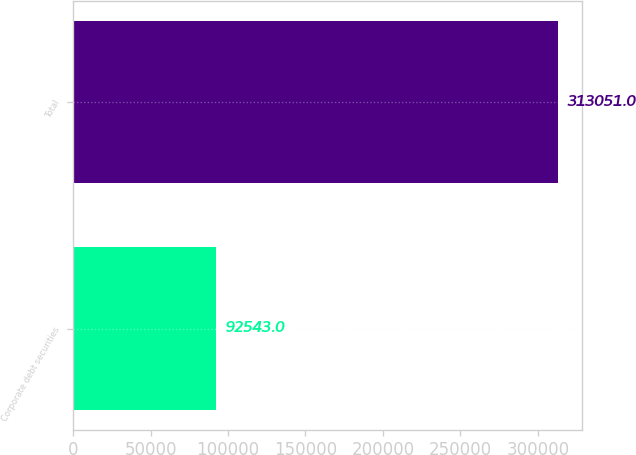Convert chart to OTSL. <chart><loc_0><loc_0><loc_500><loc_500><bar_chart><fcel>Corporate debt securities<fcel>Total<nl><fcel>92543<fcel>313051<nl></chart> 